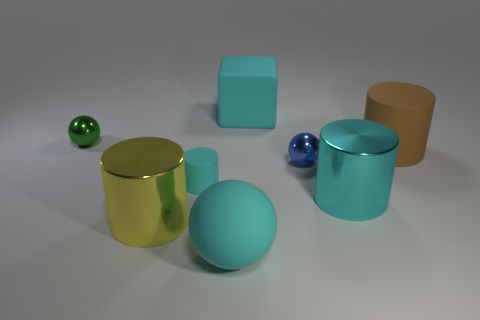Subtract all blue balls. How many cyan cylinders are left? 2 Subtract all cyan matte balls. How many balls are left? 2 Add 1 cyan cubes. How many objects exist? 9 Subtract all brown cylinders. How many cylinders are left? 3 Subtract all spheres. How many objects are left? 5 Subtract all yellow balls. Subtract all brown blocks. How many balls are left? 3 Add 3 large cyan metal objects. How many large cyan metal objects are left? 4 Add 7 small blue balls. How many small blue balls exist? 8 Subtract 0 brown balls. How many objects are left? 8 Subtract all green spheres. Subtract all red metallic cylinders. How many objects are left? 7 